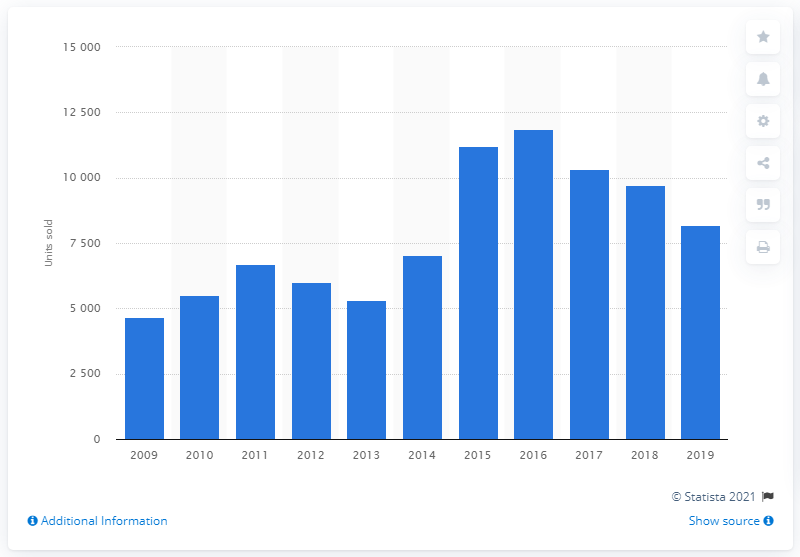Indicate a few pertinent items in this graphic. In 2016, a total of 11,878 Nissan cars were sold in Ireland. 